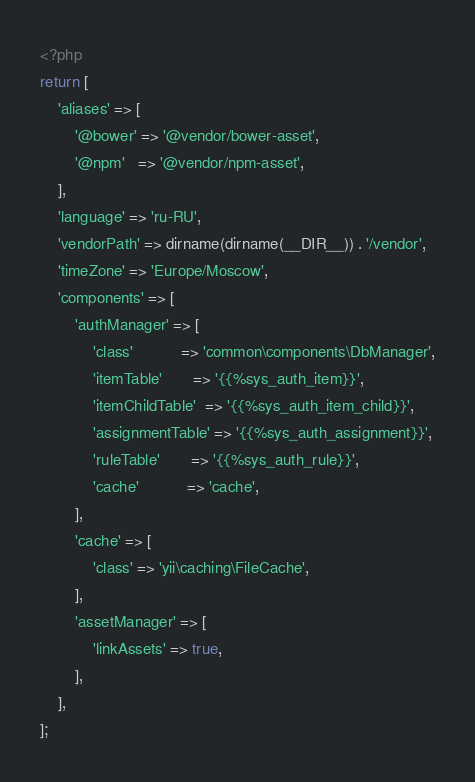Convert code to text. <code><loc_0><loc_0><loc_500><loc_500><_PHP_><?php
return [
    'aliases' => [
        '@bower' => '@vendor/bower-asset',
        '@npm'   => '@vendor/npm-asset',
    ],
    'language' => 'ru-RU',
    'vendorPath' => dirname(dirname(__DIR__)) . '/vendor',
    'timeZone' => 'Europe/Moscow',
    'components' => [
        'authManager' => [
            'class'           => 'common\components\DbManager',
            'itemTable'       => '{{%sys_auth_item}}',
            'itemChildTable'  => '{{%sys_auth_item_child}}',
            'assignmentTable' => '{{%sys_auth_assignment}}',
            'ruleTable'       => '{{%sys_auth_rule}}',
            'cache'           => 'cache',
        ],
        'cache' => [
            'class' => 'yii\caching\FileCache',
        ],
        'assetManager' => [
            'linkAssets' => true,
        ],
    ],
];
</code> 